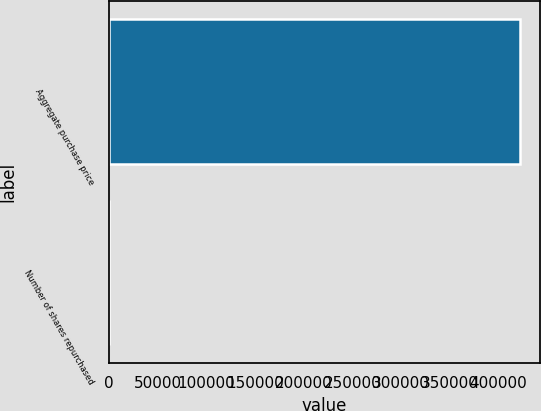<chart> <loc_0><loc_0><loc_500><loc_500><bar_chart><fcel>Aggregate purchase price<fcel>Number of shares repurchased<nl><fcel>422166<fcel>167<nl></chart> 